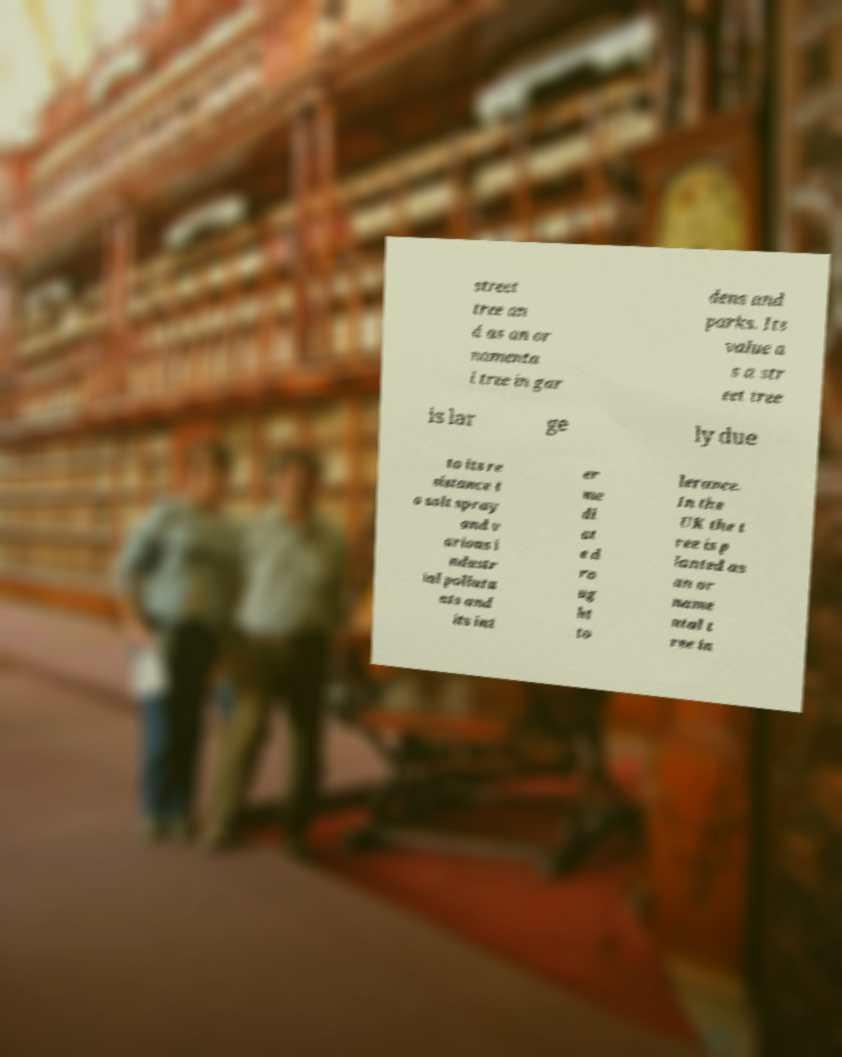I need the written content from this picture converted into text. Can you do that? street tree an d as an or namenta l tree in gar dens and parks. Its value a s a str eet tree is lar ge ly due to its re sistance t o salt spray and v arious i ndustr ial polluta nts and its int er me di at e d ro ug ht to lerance. In the UK the t ree is p lanted as an or name ntal t ree in 